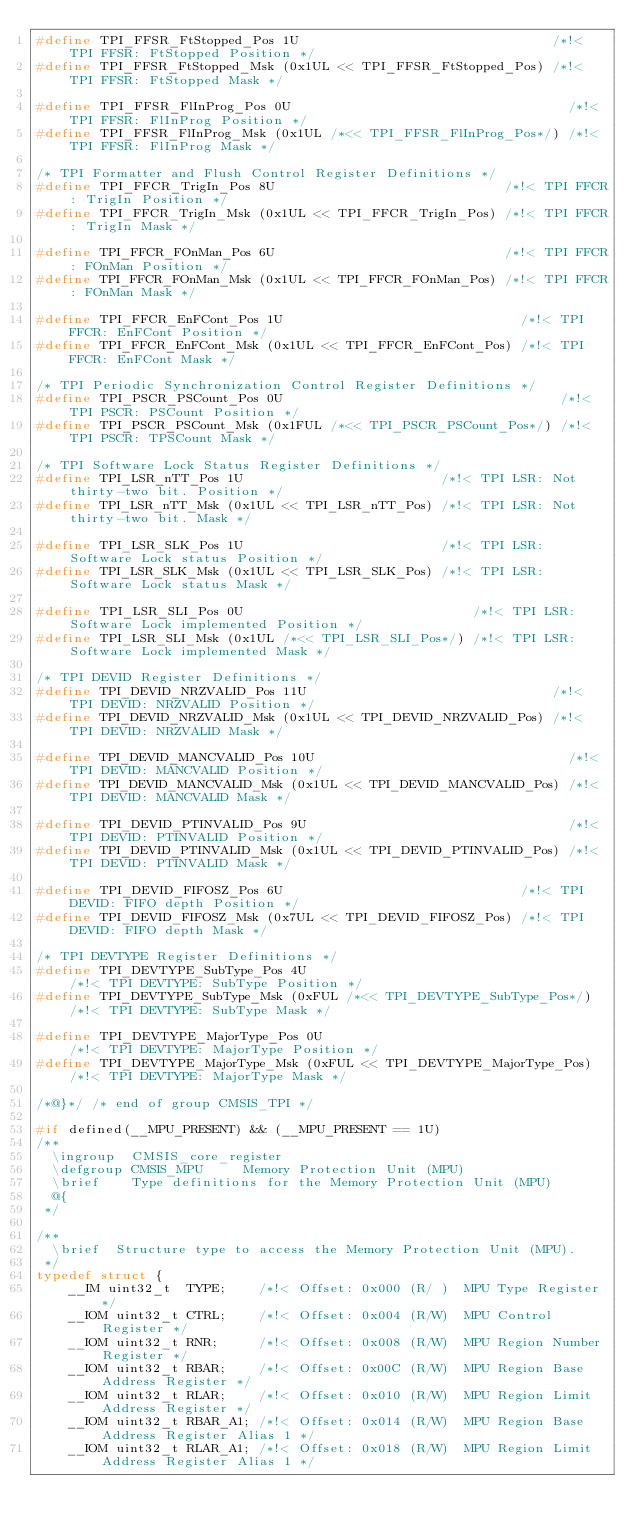Convert code to text. <code><loc_0><loc_0><loc_500><loc_500><_C_>#define TPI_FFSR_FtStopped_Pos 1U                                /*!< TPI FFSR: FtStopped Position */
#define TPI_FFSR_FtStopped_Msk (0x1UL << TPI_FFSR_FtStopped_Pos) /*!< TPI FFSR: FtStopped Mask */

#define TPI_FFSR_FlInProg_Pos 0U                                   /*!< TPI FFSR: FlInProg Position */
#define TPI_FFSR_FlInProg_Msk (0x1UL /*<< TPI_FFSR_FlInProg_Pos*/) /*!< TPI FFSR: FlInProg Mask */

/* TPI Formatter and Flush Control Register Definitions */
#define TPI_FFCR_TrigIn_Pos 8U                             /*!< TPI FFCR: TrigIn Position */
#define TPI_FFCR_TrigIn_Msk (0x1UL << TPI_FFCR_TrigIn_Pos) /*!< TPI FFCR: TrigIn Mask */

#define TPI_FFCR_FOnMan_Pos 6U                             /*!< TPI FFCR: FOnMan Position */
#define TPI_FFCR_FOnMan_Msk (0x1UL << TPI_FFCR_FOnMan_Pos) /*!< TPI FFCR: FOnMan Mask */

#define TPI_FFCR_EnFCont_Pos 1U                              /*!< TPI FFCR: EnFCont Position */
#define TPI_FFCR_EnFCont_Msk (0x1UL << TPI_FFCR_EnFCont_Pos) /*!< TPI FFCR: EnFCont Mask */

/* TPI Periodic Synchronization Control Register Definitions */
#define TPI_PSCR_PSCount_Pos 0U                                   /*!< TPI PSCR: PSCount Position */
#define TPI_PSCR_PSCount_Msk (0x1FUL /*<< TPI_PSCR_PSCount_Pos*/) /*!< TPI PSCR: TPSCount Mask */

/* TPI Software Lock Status Register Definitions */
#define TPI_LSR_nTT_Pos 1U                         /*!< TPI LSR: Not thirty-two bit. Position */
#define TPI_LSR_nTT_Msk (0x1UL << TPI_LSR_nTT_Pos) /*!< TPI LSR: Not thirty-two bit. Mask */

#define TPI_LSR_SLK_Pos 1U                         /*!< TPI LSR: Software Lock status Position */
#define TPI_LSR_SLK_Msk (0x1UL << TPI_LSR_SLK_Pos) /*!< TPI LSR: Software Lock status Mask */

#define TPI_LSR_SLI_Pos 0U                             /*!< TPI LSR: Software Lock implemented Position */
#define TPI_LSR_SLI_Msk (0x1UL /*<< TPI_LSR_SLI_Pos*/) /*!< TPI LSR: Software Lock implemented Mask */

/* TPI DEVID Register Definitions */
#define TPI_DEVID_NRZVALID_Pos 11U                               /*!< TPI DEVID: NRZVALID Position */
#define TPI_DEVID_NRZVALID_Msk (0x1UL << TPI_DEVID_NRZVALID_Pos) /*!< TPI DEVID: NRZVALID Mask */

#define TPI_DEVID_MANCVALID_Pos 10U                                /*!< TPI DEVID: MANCVALID Position */
#define TPI_DEVID_MANCVALID_Msk (0x1UL << TPI_DEVID_MANCVALID_Pos) /*!< TPI DEVID: MANCVALID Mask */

#define TPI_DEVID_PTINVALID_Pos 9U                                 /*!< TPI DEVID: PTINVALID Position */
#define TPI_DEVID_PTINVALID_Msk (0x1UL << TPI_DEVID_PTINVALID_Pos) /*!< TPI DEVID: PTINVALID Mask */

#define TPI_DEVID_FIFOSZ_Pos 6U                              /*!< TPI DEVID: FIFO depth Position */
#define TPI_DEVID_FIFOSZ_Msk (0x7UL << TPI_DEVID_FIFOSZ_Pos) /*!< TPI DEVID: FIFO depth Mask */

/* TPI DEVTYPE Register Definitions */
#define TPI_DEVTYPE_SubType_Pos 4U                                     /*!< TPI DEVTYPE: SubType Position */
#define TPI_DEVTYPE_SubType_Msk (0xFUL /*<< TPI_DEVTYPE_SubType_Pos*/) /*!< TPI DEVTYPE: SubType Mask */

#define TPI_DEVTYPE_MajorType_Pos 0U                                   /*!< TPI DEVTYPE: MajorType Position */
#define TPI_DEVTYPE_MajorType_Msk (0xFUL << TPI_DEVTYPE_MajorType_Pos) /*!< TPI DEVTYPE: MajorType Mask */

/*@}*/ /* end of group CMSIS_TPI */

#if defined(__MPU_PRESENT) && (__MPU_PRESENT == 1U)
/**
  \ingroup  CMSIS_core_register
  \defgroup CMSIS_MPU     Memory Protection Unit (MPU)
  \brief    Type definitions for the Memory Protection Unit (MPU)
  @{
 */

/**
  \brief  Structure type to access the Memory Protection Unit (MPU).
 */
typedef struct {
    __IM uint32_t  TYPE;    /*!< Offset: 0x000 (R/ )  MPU Type Register */
    __IOM uint32_t CTRL;    /*!< Offset: 0x004 (R/W)  MPU Control Register */
    __IOM uint32_t RNR;     /*!< Offset: 0x008 (R/W)  MPU Region Number Register */
    __IOM uint32_t RBAR;    /*!< Offset: 0x00C (R/W)  MPU Region Base Address Register */
    __IOM uint32_t RLAR;    /*!< Offset: 0x010 (R/W)  MPU Region Limit Address Register */
    __IOM uint32_t RBAR_A1; /*!< Offset: 0x014 (R/W)  MPU Region Base Address Register Alias 1 */
    __IOM uint32_t RLAR_A1; /*!< Offset: 0x018 (R/W)  MPU Region Limit Address Register Alias 1 */</code> 